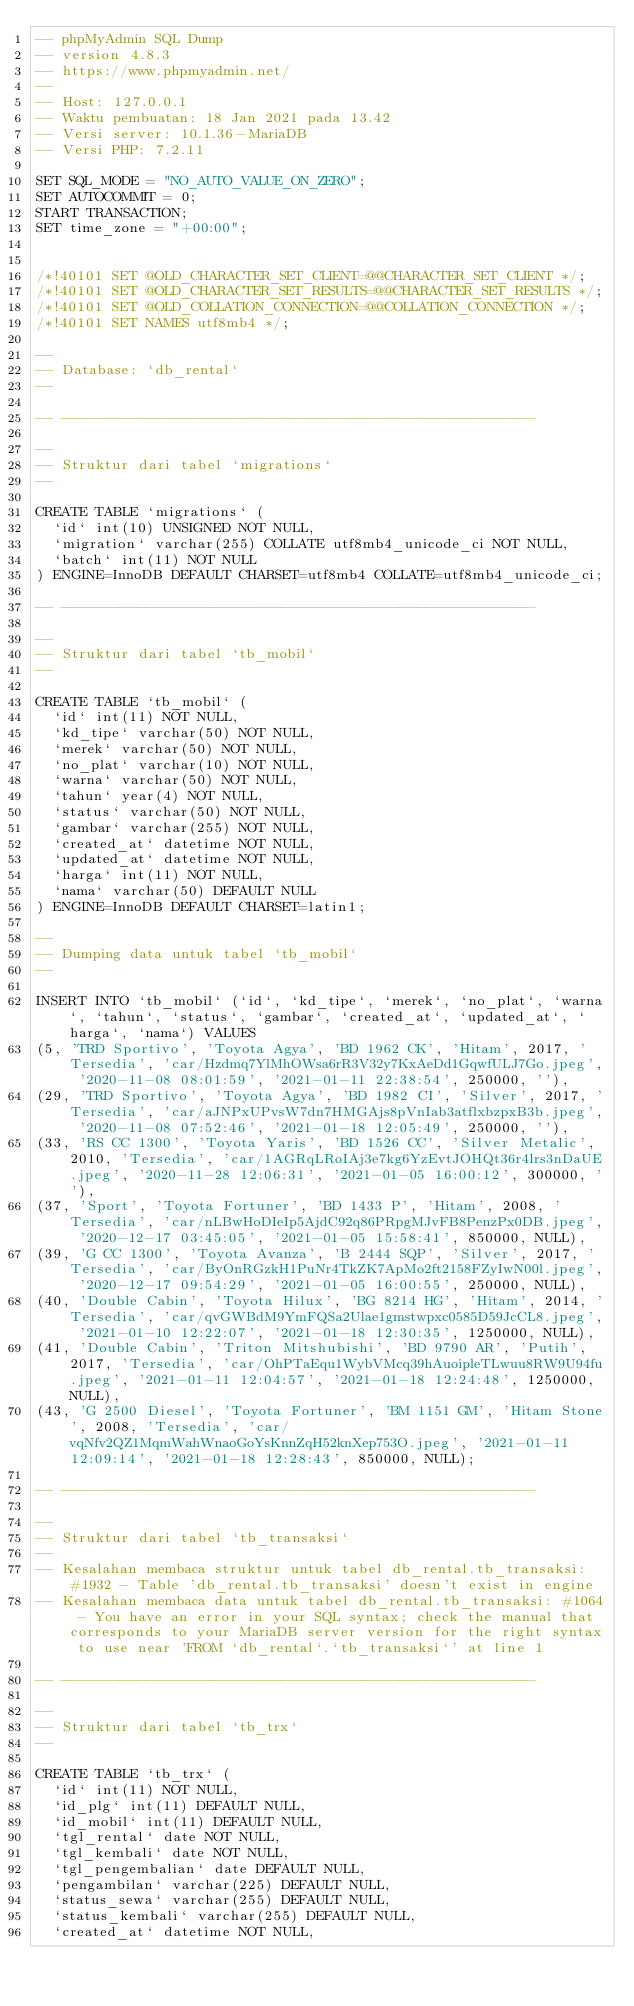<code> <loc_0><loc_0><loc_500><loc_500><_SQL_>-- phpMyAdmin SQL Dump
-- version 4.8.3
-- https://www.phpmyadmin.net/
--
-- Host: 127.0.0.1
-- Waktu pembuatan: 18 Jan 2021 pada 13.42
-- Versi server: 10.1.36-MariaDB
-- Versi PHP: 7.2.11

SET SQL_MODE = "NO_AUTO_VALUE_ON_ZERO";
SET AUTOCOMMIT = 0;
START TRANSACTION;
SET time_zone = "+00:00";


/*!40101 SET @OLD_CHARACTER_SET_CLIENT=@@CHARACTER_SET_CLIENT */;
/*!40101 SET @OLD_CHARACTER_SET_RESULTS=@@CHARACTER_SET_RESULTS */;
/*!40101 SET @OLD_COLLATION_CONNECTION=@@COLLATION_CONNECTION */;
/*!40101 SET NAMES utf8mb4 */;

--
-- Database: `db_rental`
--

-- --------------------------------------------------------

--
-- Struktur dari tabel `migrations`
--

CREATE TABLE `migrations` (
  `id` int(10) UNSIGNED NOT NULL,
  `migration` varchar(255) COLLATE utf8mb4_unicode_ci NOT NULL,
  `batch` int(11) NOT NULL
) ENGINE=InnoDB DEFAULT CHARSET=utf8mb4 COLLATE=utf8mb4_unicode_ci;

-- --------------------------------------------------------

--
-- Struktur dari tabel `tb_mobil`
--

CREATE TABLE `tb_mobil` (
  `id` int(11) NOT NULL,
  `kd_tipe` varchar(50) NOT NULL,
  `merek` varchar(50) NOT NULL,
  `no_plat` varchar(10) NOT NULL,
  `warna` varchar(50) NOT NULL,
  `tahun` year(4) NOT NULL,
  `status` varchar(50) NOT NULL,
  `gambar` varchar(255) NOT NULL,
  `created_at` datetime NOT NULL,
  `updated_at` datetime NOT NULL,
  `harga` int(11) NOT NULL,
  `nama` varchar(50) DEFAULT NULL
) ENGINE=InnoDB DEFAULT CHARSET=latin1;

--
-- Dumping data untuk tabel `tb_mobil`
--

INSERT INTO `tb_mobil` (`id`, `kd_tipe`, `merek`, `no_plat`, `warna`, `tahun`, `status`, `gambar`, `created_at`, `updated_at`, `harga`, `nama`) VALUES
(5, 'TRD Sportivo', 'Toyota Agya', 'BD 1962 CK', 'Hitam', 2017, 'Tersedia', 'car/Hzdmq7YlMhOWsa6rR3V32y7KxAeDd1GqwfULJ7Go.jpeg', '2020-11-08 08:01:59', '2021-01-11 22:38:54', 250000, ''),
(29, 'TRD Sportivo', 'Toyota Agya', 'BD 1982 CI', 'Silver', 2017, 'Tersedia', 'car/aJNPxUPvsW7dn7HMGAjs8pVnIab3atflxbzpxB3b.jpeg', '2020-11-08 07:52:46', '2021-01-18 12:05:49', 250000, ''),
(33, 'RS CC 1300', 'Toyota Yaris', 'BD 1526 CC', 'Silver Metalic', 2010, 'Tersedia', 'car/1AGRqLRoIAj3e7kg6YzEvtJOHQt36r4lrs3nDaUE.jpeg', '2020-11-28 12:06:31', '2021-01-05 16:00:12', 300000, ''),
(37, 'Sport', 'Toyota Fortuner', 'BD 1433 P', 'Hitam', 2008, 'Tersedia', 'car/nLBwHoDIeIp5AjdC92q86PRpgMJvFB8PenzPx0DB.jpeg', '2020-12-17 03:45:05', '2021-01-05 15:58:41', 850000, NULL),
(39, 'G CC 1300', 'Toyota Avanza', 'B 2444 SQP', 'Silver', 2017, 'Tersedia', 'car/ByOnRGzkH1PuNr4TkZK7ApMo2ft2158FZyIwN00l.jpeg', '2020-12-17 09:54:29', '2021-01-05 16:00:55', 250000, NULL),
(40, 'Double Cabin', 'Toyota Hilux', 'BG 8214 HG', 'Hitam', 2014, 'Tersedia', 'car/qvGWBdM9YmFQSa2Ulae1gmstwpxc0585D59JcCL8.jpeg', '2021-01-10 12:22:07', '2021-01-18 12:30:35', 1250000, NULL),
(41, 'Double Cabin', 'Triton Mitshubishi', 'BD 9790 AR', 'Putih', 2017, 'Tersedia', 'car/OhPTaEqu1WybVMcq39hAuoipleTLwuu8RW9U94fu.jpeg', '2021-01-11 12:04:57', '2021-01-18 12:24:48', 1250000, NULL),
(43, 'G 2500 Diesel', 'Toyota Fortuner', 'BM 1151 GM', 'Hitam Stone', 2008, 'Tersedia', 'car/vqNfv2QZ1MqmWahWnaoGoYsKnnZqH52knXep753O.jpeg', '2021-01-11 12:09:14', '2021-01-18 12:28:43', 850000, NULL);

-- --------------------------------------------------------

--
-- Struktur dari tabel `tb_transaksi`
--
-- Kesalahan membaca struktur untuk tabel db_rental.tb_transaksi: #1932 - Table 'db_rental.tb_transaksi' doesn't exist in engine
-- Kesalahan membaca data untuk tabel db_rental.tb_transaksi: #1064 - You have an error in your SQL syntax; check the manual that corresponds to your MariaDB server version for the right syntax to use near 'FROM `db_rental`.`tb_transaksi`' at line 1

-- --------------------------------------------------------

--
-- Struktur dari tabel `tb_trx`
--

CREATE TABLE `tb_trx` (
  `id` int(11) NOT NULL,
  `id_plg` int(11) DEFAULT NULL,
  `id_mobil` int(11) DEFAULT NULL,
  `tgl_rental` date NOT NULL,
  `tgl_kembali` date NOT NULL,
  `tgl_pengembalian` date DEFAULT NULL,
  `pengambilan` varchar(225) DEFAULT NULL,
  `status_sewa` varchar(255) DEFAULT NULL,
  `status_kembali` varchar(255) DEFAULT NULL,
  `created_at` datetime NOT NULL,</code> 